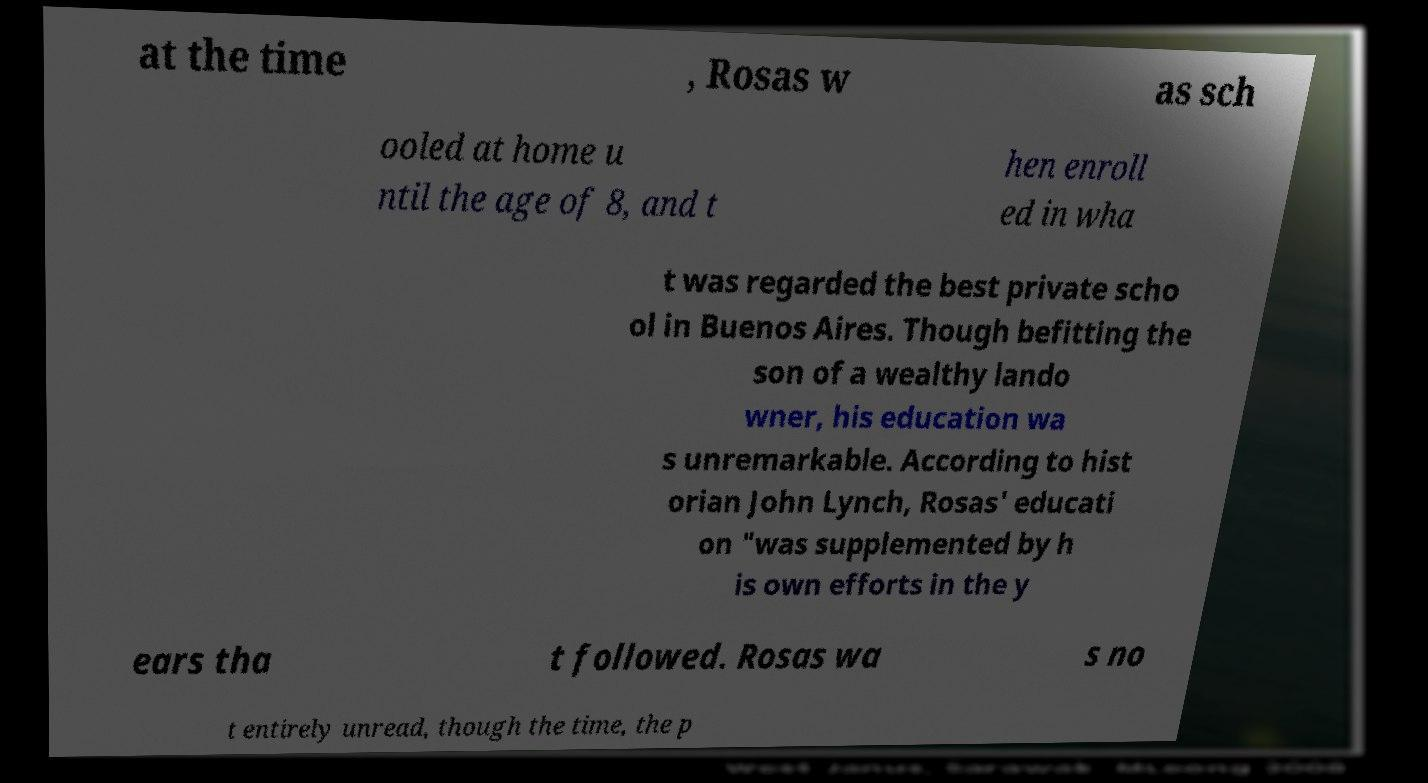Can you accurately transcribe the text from the provided image for me? at the time , Rosas w as sch ooled at home u ntil the age of 8, and t hen enroll ed in wha t was regarded the best private scho ol in Buenos Aires. Though befitting the son of a wealthy lando wner, his education wa s unremarkable. According to hist orian John Lynch, Rosas' educati on "was supplemented by h is own efforts in the y ears tha t followed. Rosas wa s no t entirely unread, though the time, the p 